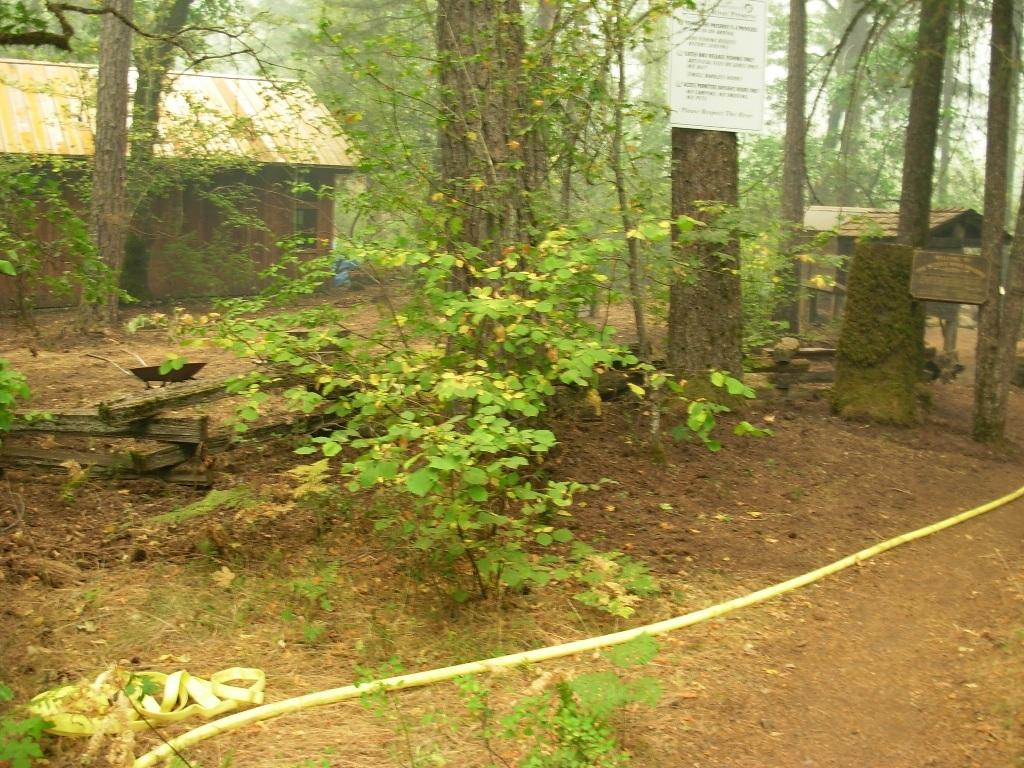What type of vegetation can be seen in the image? There are trees in the image. What structures are present in the image? There are sheds in the image. How are the trees being utilized in the image? Boards are placed on the trees. What can be seen at the bottom of the image? There is a pipe at the bottom of the image. What type of barrier is visible in the image? There is a fence in the image. How many brothers are depicted interacting with the horses near the lamp in the image? There are no brothers, horses, or lamps present in the image. 